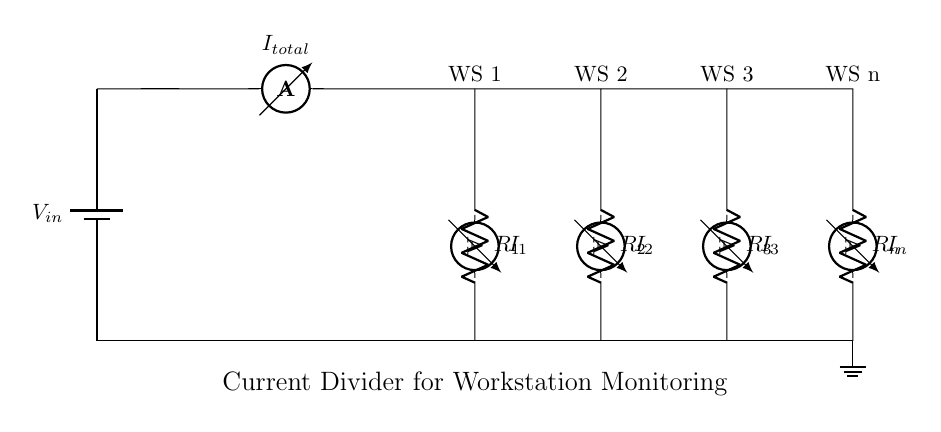What is the total current flowing through the circuit? The total current can be found at the ammeter labeled I_total, directly after the battery. In this case, the value is not provided in the code but is represented as the total current entering the branches.
Answer: I_total What are the resistances in the current divider branches? The circuit diagram includes four resistors: R_1, R_2, R_3, and R_n. Each of these is marked next to their respective current paths, indicating they are the current divider's components.
Answer: R_1, R_2, R_3, R_n How many workstations are connected in this circuit? The circuit diagram shows four distinct workstations, each labeled WS 1, WS 2, WS 3, and WS n, indicating that they all receive current from the divider.
Answer: Four What does the ammeter in each branch measure? The ammeters labeled I_1, I_2, I_3, and I_n measure the current flowing through each respective branch from the current divider. Each current is the amount of current being used by its connected workstation.
Answer: Branch current Which workstation has the highest current draw? To determine which workstation has the highest current draw, one would need to compare the values of I_1, I_2, I_3, and I_n visually or experimentally. Since specific values aren’t given in the circuit, it can’t be determined from this setup alone.
Answer: Indeterminate What is the purpose of the current divider in this circuit? The current divider redistributes the total current from the power supply into multiple paths for various workstations. Each workstation requires current, and this setup allows for monitoring and balancing the draw between them effectively.
Answer: Current redistribution 